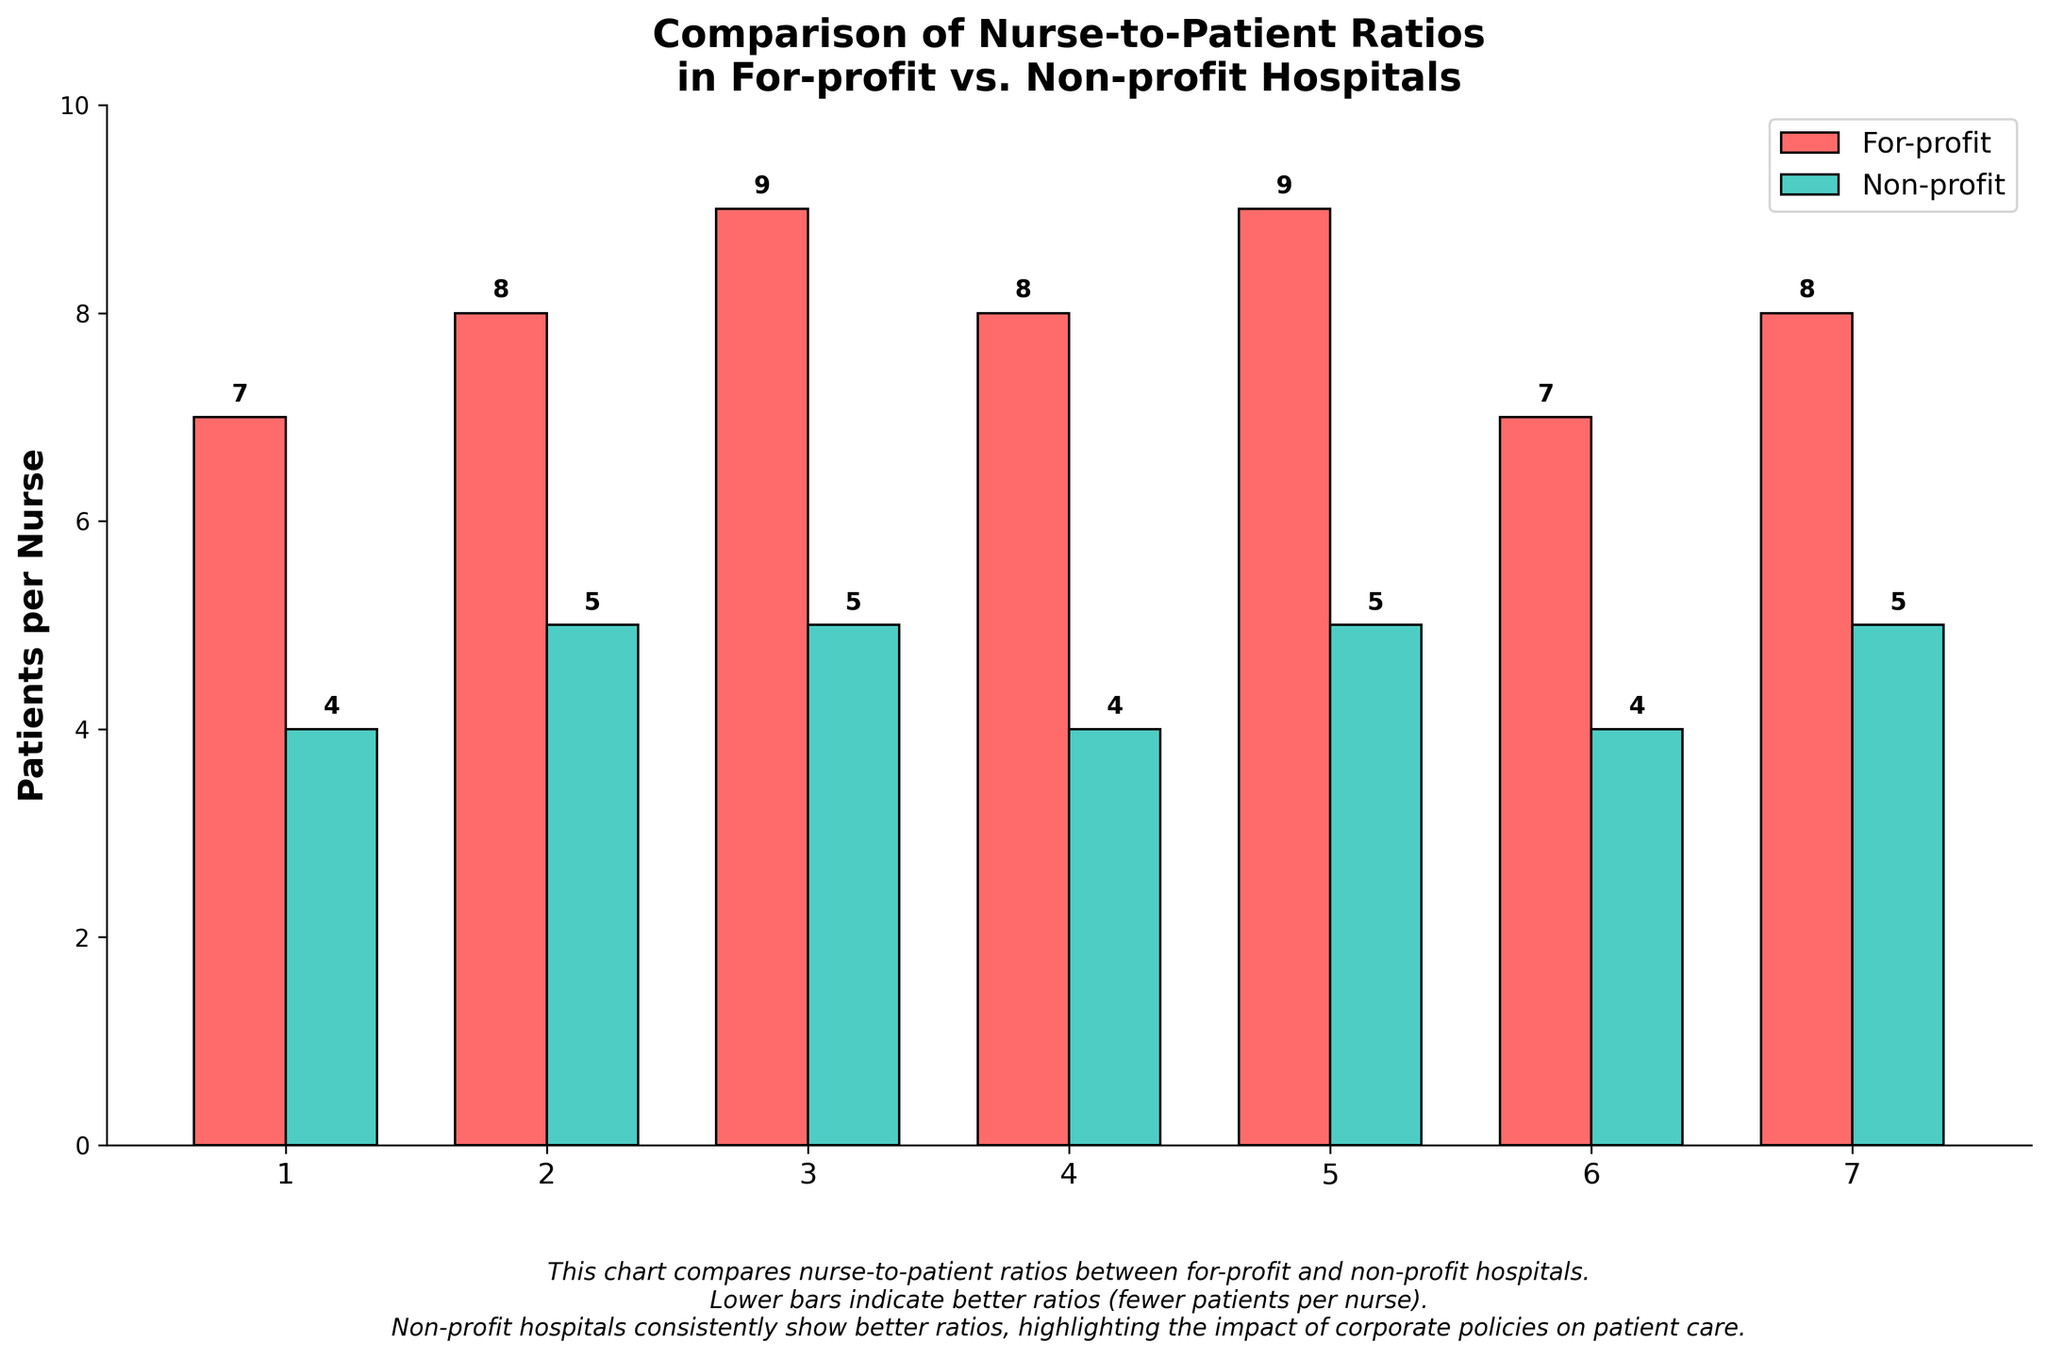What's the nurse-to-patient ratio for for-profit hospitals on average? First, extract the different nurse-to-patient ratios for for-profit hospitals (7, 8, 9, 8, 9, 7, 8). Sum these values (7+8+9+8+9+7+8 = 56). There are 7 for-profit hospitals, so divide the sum by 7 (56/7).
Answer: 8 Which type of hospital has better nurse-to-patient ratios on average? Calculate the average nurse-to-patient ratio for both for-profit and non-profit hospitals. For for-profit (7, 8, 9, 8, 9, 7, 8), the sum is 56 and the average is 8 (as previously shown). For non-profit (4, 5, 5, 4, 5, 4, 5), the sum is 32 and the average is 4.57 (32/7). Non-profit hospitals have a better (lower) average ratio.
Answer: Non-profit What can you infer from the color of the bars on the chart? The chart uses color to distinguish between for-profit and non-profit hospitals. Red bars represent for-profit hospitals, and green bars represent non-profit hospitals, indicating two categories with different nurse-to-patient ratios.
Answer: Red for for-profit, green for non-profit How does the nurse-to-patient ratio compare between the best non-profit and the worst for-profit hospital? The best non-profit hospital has a ratio of 4 (Mayo Clinic, Johns Hopkins Hospital, Massachusetts General Hospital). The worst for-profit hospital has a ratio of 9 (Community Health Systems, LifePoint Health). Non-profits generally have better ratios.
Answer: Non-profits have better ratios Which hospital has the worst nurse-to-patient ratio? By identifying the highest nurse-to-patient ratios, we find that Community Health Systems and LifePoint Health (both for-profit hospitals) have the worst ratios at 9.
Answer: Community Health Systems, LifePoint Health How many non-profit hospitals have ratios equal to 5? Review the list of non-profit hospitals and count the number of times ratios of 5 appear. The hospitals with ratios of 5 are Cleveland Clinic, Kaiser Permanente, Mount Sinai Hospital, and NewYork-Presbyterian Hospital. There are 4 such instances.
Answer: 4 If one more non-profit hospital with a ratio of 4 is added, what would be the new average ratio for non-profit hospitals? Initially, the sum of the ratios for non-profit hospitals (4, 5, 5, 4, 5, 4, 5) is 32 with 7 hospitals. Adding another hospital with a ratio of 4 makes the sum 36 and the count 8. The new average would be 36/8 = 4.5.
Answer: 4.5 What is the difference between the highest and lowest nurse-to-patient ratios across all hospitals? Identify the highest nurse-to-patient ratio (9, for Community Health Systems and LifePoint Health) and the lowest (4, for several non-profit hospitals). The difference is 9 - 4.
Answer: 5 Are all non-profit hospitals' nurse-to-patient ratios better than all for-profit hospitals? Compare each ratio from non-profit hospitals (4, 5, 5, 4, 5, 4, 5) with those of for-profit hospitals (7, 8, 9, 8, 9, 7, 8). All non-profit ratios are lower than the lowest for-profit ratio (7).
Answer: Yes What percentage of for-profit hospitals have a nurse-to-patient ratio greater than or equal to 8? Out of 7 for-profit hospitals, 4 have a ratio of 8 or 9 (8, 9, 8, 9, 8), so the percentage is (4/7)*100.
Answer: ~57% 